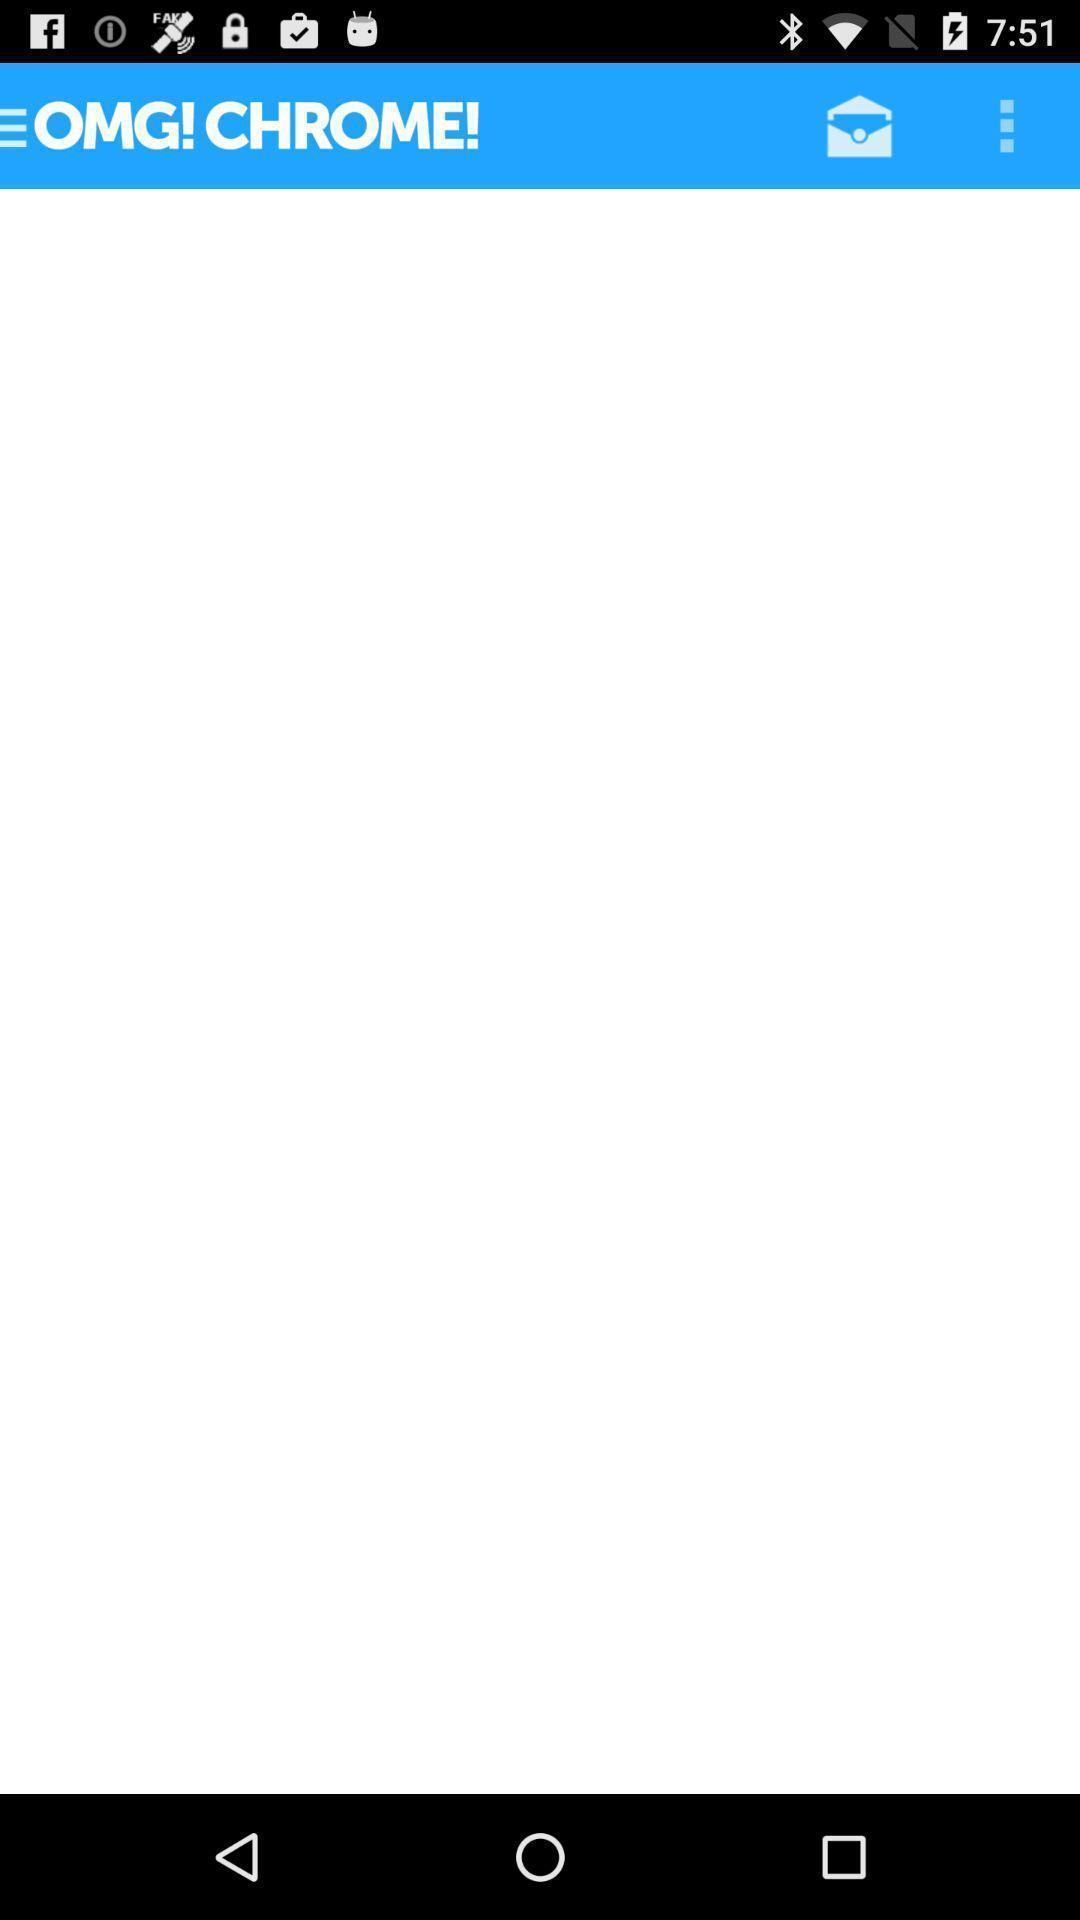Describe the visual elements of this screenshot. Screen showing page. 